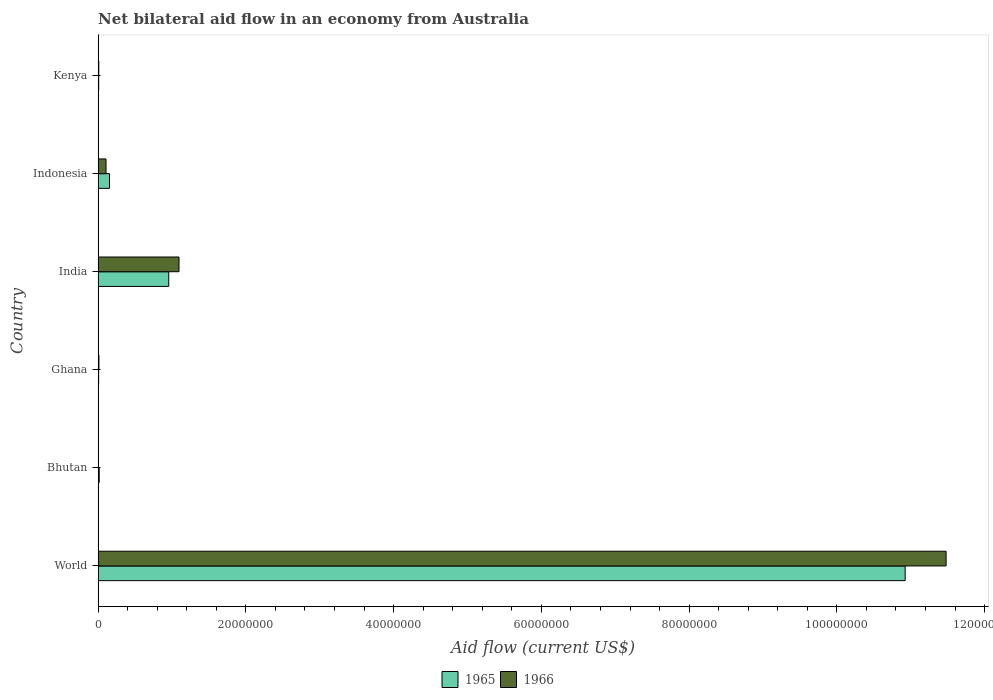How many groups of bars are there?
Provide a short and direct response. 6. What is the net bilateral aid flow in 1965 in Ghana?
Your response must be concise. 7.00e+04. Across all countries, what is the maximum net bilateral aid flow in 1966?
Offer a terse response. 1.15e+08. In which country was the net bilateral aid flow in 1965 maximum?
Provide a succinct answer. World. In which country was the net bilateral aid flow in 1965 minimum?
Give a very brief answer. Ghana. What is the total net bilateral aid flow in 1966 in the graph?
Offer a very short reply. 1.27e+08. What is the difference between the net bilateral aid flow in 1965 in Bhutan and that in India?
Your answer should be compact. -9.41e+06. What is the difference between the net bilateral aid flow in 1965 in India and the net bilateral aid flow in 1966 in Kenya?
Your response must be concise. 9.47e+06. What is the average net bilateral aid flow in 1965 per country?
Offer a terse response. 2.01e+07. In how many countries, is the net bilateral aid flow in 1966 greater than 76000000 US$?
Provide a short and direct response. 1. What is the ratio of the net bilateral aid flow in 1965 in Indonesia to that in World?
Keep it short and to the point. 0.01. What is the difference between the highest and the second highest net bilateral aid flow in 1966?
Provide a short and direct response. 1.04e+08. What is the difference between the highest and the lowest net bilateral aid flow in 1965?
Keep it short and to the point. 1.09e+08. What does the 1st bar from the top in Kenya represents?
Your answer should be compact. 1966. What does the 2nd bar from the bottom in World represents?
Provide a succinct answer. 1966. How many bars are there?
Make the answer very short. 12. Are all the bars in the graph horizontal?
Make the answer very short. Yes. What is the difference between two consecutive major ticks on the X-axis?
Your response must be concise. 2.00e+07. Does the graph contain any zero values?
Make the answer very short. No. Does the graph contain grids?
Keep it short and to the point. No. Where does the legend appear in the graph?
Offer a terse response. Bottom center. How are the legend labels stacked?
Give a very brief answer. Horizontal. What is the title of the graph?
Ensure brevity in your answer.  Net bilateral aid flow in an economy from Australia. What is the label or title of the Y-axis?
Provide a short and direct response. Country. What is the Aid flow (current US$) in 1965 in World?
Offer a terse response. 1.09e+08. What is the Aid flow (current US$) of 1966 in World?
Offer a very short reply. 1.15e+08. What is the Aid flow (current US$) of 1965 in Bhutan?
Your response must be concise. 1.50e+05. What is the Aid flow (current US$) of 1965 in Ghana?
Your answer should be compact. 7.00e+04. What is the Aid flow (current US$) of 1966 in Ghana?
Give a very brief answer. 1.10e+05. What is the Aid flow (current US$) of 1965 in India?
Your answer should be very brief. 9.56e+06. What is the Aid flow (current US$) in 1966 in India?
Offer a very short reply. 1.10e+07. What is the Aid flow (current US$) of 1965 in Indonesia?
Offer a terse response. 1.54e+06. What is the Aid flow (current US$) of 1966 in Indonesia?
Provide a succinct answer. 1.07e+06. Across all countries, what is the maximum Aid flow (current US$) of 1965?
Make the answer very short. 1.09e+08. Across all countries, what is the maximum Aid flow (current US$) in 1966?
Ensure brevity in your answer.  1.15e+08. Across all countries, what is the minimum Aid flow (current US$) in 1966?
Offer a very short reply. 2.00e+04. What is the total Aid flow (current US$) in 1965 in the graph?
Ensure brevity in your answer.  1.21e+08. What is the total Aid flow (current US$) in 1966 in the graph?
Offer a very short reply. 1.27e+08. What is the difference between the Aid flow (current US$) of 1965 in World and that in Bhutan?
Your answer should be very brief. 1.09e+08. What is the difference between the Aid flow (current US$) in 1966 in World and that in Bhutan?
Keep it short and to the point. 1.15e+08. What is the difference between the Aid flow (current US$) in 1965 in World and that in Ghana?
Offer a terse response. 1.09e+08. What is the difference between the Aid flow (current US$) of 1966 in World and that in Ghana?
Offer a very short reply. 1.15e+08. What is the difference between the Aid flow (current US$) of 1965 in World and that in India?
Make the answer very short. 9.97e+07. What is the difference between the Aid flow (current US$) of 1966 in World and that in India?
Provide a short and direct response. 1.04e+08. What is the difference between the Aid flow (current US$) in 1965 in World and that in Indonesia?
Offer a very short reply. 1.08e+08. What is the difference between the Aid flow (current US$) of 1966 in World and that in Indonesia?
Your answer should be compact. 1.14e+08. What is the difference between the Aid flow (current US$) in 1965 in World and that in Kenya?
Offer a very short reply. 1.09e+08. What is the difference between the Aid flow (current US$) of 1966 in World and that in Kenya?
Make the answer very short. 1.15e+08. What is the difference between the Aid flow (current US$) of 1965 in Bhutan and that in Ghana?
Keep it short and to the point. 8.00e+04. What is the difference between the Aid flow (current US$) in 1966 in Bhutan and that in Ghana?
Offer a very short reply. -9.00e+04. What is the difference between the Aid flow (current US$) of 1965 in Bhutan and that in India?
Provide a succinct answer. -9.41e+06. What is the difference between the Aid flow (current US$) of 1966 in Bhutan and that in India?
Your answer should be compact. -1.09e+07. What is the difference between the Aid flow (current US$) of 1965 in Bhutan and that in Indonesia?
Offer a terse response. -1.39e+06. What is the difference between the Aid flow (current US$) of 1966 in Bhutan and that in Indonesia?
Provide a short and direct response. -1.05e+06. What is the difference between the Aid flow (current US$) in 1966 in Bhutan and that in Kenya?
Give a very brief answer. -7.00e+04. What is the difference between the Aid flow (current US$) in 1965 in Ghana and that in India?
Ensure brevity in your answer.  -9.49e+06. What is the difference between the Aid flow (current US$) in 1966 in Ghana and that in India?
Your answer should be very brief. -1.08e+07. What is the difference between the Aid flow (current US$) of 1965 in Ghana and that in Indonesia?
Your response must be concise. -1.47e+06. What is the difference between the Aid flow (current US$) of 1966 in Ghana and that in Indonesia?
Offer a very short reply. -9.60e+05. What is the difference between the Aid flow (current US$) of 1965 in Ghana and that in Kenya?
Keep it short and to the point. -10000. What is the difference between the Aid flow (current US$) of 1966 in Ghana and that in Kenya?
Give a very brief answer. 2.00e+04. What is the difference between the Aid flow (current US$) of 1965 in India and that in Indonesia?
Give a very brief answer. 8.02e+06. What is the difference between the Aid flow (current US$) in 1966 in India and that in Indonesia?
Keep it short and to the point. 9.88e+06. What is the difference between the Aid flow (current US$) in 1965 in India and that in Kenya?
Provide a succinct answer. 9.48e+06. What is the difference between the Aid flow (current US$) in 1966 in India and that in Kenya?
Your response must be concise. 1.09e+07. What is the difference between the Aid flow (current US$) of 1965 in Indonesia and that in Kenya?
Your answer should be compact. 1.46e+06. What is the difference between the Aid flow (current US$) in 1966 in Indonesia and that in Kenya?
Offer a very short reply. 9.80e+05. What is the difference between the Aid flow (current US$) of 1965 in World and the Aid flow (current US$) of 1966 in Bhutan?
Offer a terse response. 1.09e+08. What is the difference between the Aid flow (current US$) in 1965 in World and the Aid flow (current US$) in 1966 in Ghana?
Make the answer very short. 1.09e+08. What is the difference between the Aid flow (current US$) of 1965 in World and the Aid flow (current US$) of 1966 in India?
Provide a succinct answer. 9.83e+07. What is the difference between the Aid flow (current US$) of 1965 in World and the Aid flow (current US$) of 1966 in Indonesia?
Ensure brevity in your answer.  1.08e+08. What is the difference between the Aid flow (current US$) of 1965 in World and the Aid flow (current US$) of 1966 in Kenya?
Provide a succinct answer. 1.09e+08. What is the difference between the Aid flow (current US$) in 1965 in Bhutan and the Aid flow (current US$) in 1966 in India?
Your answer should be very brief. -1.08e+07. What is the difference between the Aid flow (current US$) in 1965 in Bhutan and the Aid flow (current US$) in 1966 in Indonesia?
Give a very brief answer. -9.20e+05. What is the difference between the Aid flow (current US$) of 1965 in Bhutan and the Aid flow (current US$) of 1966 in Kenya?
Ensure brevity in your answer.  6.00e+04. What is the difference between the Aid flow (current US$) of 1965 in Ghana and the Aid flow (current US$) of 1966 in India?
Your answer should be compact. -1.09e+07. What is the difference between the Aid flow (current US$) of 1965 in Ghana and the Aid flow (current US$) of 1966 in Indonesia?
Provide a short and direct response. -1.00e+06. What is the difference between the Aid flow (current US$) in 1965 in India and the Aid flow (current US$) in 1966 in Indonesia?
Make the answer very short. 8.49e+06. What is the difference between the Aid flow (current US$) of 1965 in India and the Aid flow (current US$) of 1966 in Kenya?
Offer a terse response. 9.47e+06. What is the difference between the Aid flow (current US$) of 1965 in Indonesia and the Aid flow (current US$) of 1966 in Kenya?
Keep it short and to the point. 1.45e+06. What is the average Aid flow (current US$) in 1965 per country?
Give a very brief answer. 2.01e+07. What is the average Aid flow (current US$) of 1966 per country?
Your answer should be compact. 2.12e+07. What is the difference between the Aid flow (current US$) in 1965 and Aid flow (current US$) in 1966 in World?
Provide a succinct answer. -5.54e+06. What is the difference between the Aid flow (current US$) in 1965 and Aid flow (current US$) in 1966 in India?
Your answer should be compact. -1.39e+06. What is the difference between the Aid flow (current US$) in 1965 and Aid flow (current US$) in 1966 in Indonesia?
Ensure brevity in your answer.  4.70e+05. What is the difference between the Aid flow (current US$) in 1965 and Aid flow (current US$) in 1966 in Kenya?
Your response must be concise. -10000. What is the ratio of the Aid flow (current US$) of 1965 in World to that in Bhutan?
Provide a succinct answer. 728.33. What is the ratio of the Aid flow (current US$) of 1966 in World to that in Bhutan?
Keep it short and to the point. 5739.5. What is the ratio of the Aid flow (current US$) of 1965 in World to that in Ghana?
Keep it short and to the point. 1560.71. What is the ratio of the Aid flow (current US$) of 1966 in World to that in Ghana?
Provide a short and direct response. 1043.55. What is the ratio of the Aid flow (current US$) in 1965 in World to that in India?
Provide a short and direct response. 11.43. What is the ratio of the Aid flow (current US$) in 1966 in World to that in India?
Provide a short and direct response. 10.48. What is the ratio of the Aid flow (current US$) of 1965 in World to that in Indonesia?
Provide a succinct answer. 70.94. What is the ratio of the Aid flow (current US$) in 1966 in World to that in Indonesia?
Provide a short and direct response. 107.28. What is the ratio of the Aid flow (current US$) in 1965 in World to that in Kenya?
Make the answer very short. 1365.62. What is the ratio of the Aid flow (current US$) in 1966 in World to that in Kenya?
Keep it short and to the point. 1275.44. What is the ratio of the Aid flow (current US$) in 1965 in Bhutan to that in Ghana?
Offer a terse response. 2.14. What is the ratio of the Aid flow (current US$) of 1966 in Bhutan to that in Ghana?
Offer a terse response. 0.18. What is the ratio of the Aid flow (current US$) in 1965 in Bhutan to that in India?
Offer a terse response. 0.02. What is the ratio of the Aid flow (current US$) of 1966 in Bhutan to that in India?
Keep it short and to the point. 0. What is the ratio of the Aid flow (current US$) in 1965 in Bhutan to that in Indonesia?
Give a very brief answer. 0.1. What is the ratio of the Aid flow (current US$) in 1966 in Bhutan to that in Indonesia?
Give a very brief answer. 0.02. What is the ratio of the Aid flow (current US$) in 1965 in Bhutan to that in Kenya?
Give a very brief answer. 1.88. What is the ratio of the Aid flow (current US$) in 1966 in Bhutan to that in Kenya?
Provide a succinct answer. 0.22. What is the ratio of the Aid flow (current US$) in 1965 in Ghana to that in India?
Ensure brevity in your answer.  0.01. What is the ratio of the Aid flow (current US$) of 1966 in Ghana to that in India?
Make the answer very short. 0.01. What is the ratio of the Aid flow (current US$) in 1965 in Ghana to that in Indonesia?
Your answer should be compact. 0.05. What is the ratio of the Aid flow (current US$) of 1966 in Ghana to that in Indonesia?
Provide a succinct answer. 0.1. What is the ratio of the Aid flow (current US$) of 1966 in Ghana to that in Kenya?
Offer a very short reply. 1.22. What is the ratio of the Aid flow (current US$) of 1965 in India to that in Indonesia?
Offer a terse response. 6.21. What is the ratio of the Aid flow (current US$) of 1966 in India to that in Indonesia?
Your response must be concise. 10.23. What is the ratio of the Aid flow (current US$) of 1965 in India to that in Kenya?
Provide a short and direct response. 119.5. What is the ratio of the Aid flow (current US$) in 1966 in India to that in Kenya?
Make the answer very short. 121.67. What is the ratio of the Aid flow (current US$) of 1965 in Indonesia to that in Kenya?
Provide a short and direct response. 19.25. What is the ratio of the Aid flow (current US$) in 1966 in Indonesia to that in Kenya?
Keep it short and to the point. 11.89. What is the difference between the highest and the second highest Aid flow (current US$) in 1965?
Offer a terse response. 9.97e+07. What is the difference between the highest and the second highest Aid flow (current US$) of 1966?
Provide a succinct answer. 1.04e+08. What is the difference between the highest and the lowest Aid flow (current US$) in 1965?
Your answer should be very brief. 1.09e+08. What is the difference between the highest and the lowest Aid flow (current US$) in 1966?
Give a very brief answer. 1.15e+08. 